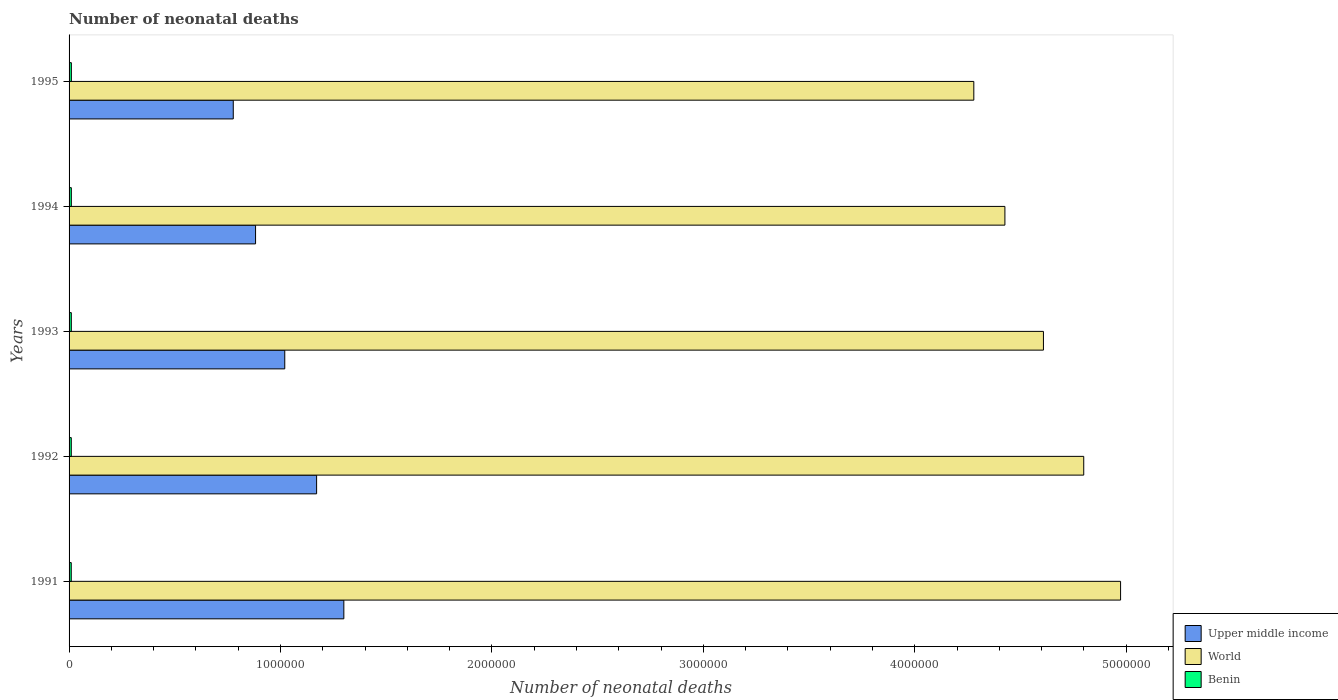How many different coloured bars are there?
Your answer should be compact. 3. How many groups of bars are there?
Provide a succinct answer. 5. How many bars are there on the 1st tick from the bottom?
Provide a short and direct response. 3. What is the label of the 3rd group of bars from the top?
Keep it short and to the point. 1993. In how many cases, is the number of bars for a given year not equal to the number of legend labels?
Offer a very short reply. 0. What is the number of neonatal deaths in in Upper middle income in 1994?
Your response must be concise. 8.82e+05. Across all years, what is the maximum number of neonatal deaths in in World?
Give a very brief answer. 4.97e+06. Across all years, what is the minimum number of neonatal deaths in in World?
Your response must be concise. 4.28e+06. In which year was the number of neonatal deaths in in Upper middle income minimum?
Provide a succinct answer. 1995. What is the total number of neonatal deaths in in Benin in the graph?
Offer a very short reply. 5.29e+04. What is the difference between the number of neonatal deaths in in Upper middle income in 1992 and that in 1993?
Your response must be concise. 1.51e+05. What is the difference between the number of neonatal deaths in in World in 1991 and the number of neonatal deaths in in Benin in 1995?
Your response must be concise. 4.96e+06. What is the average number of neonatal deaths in in Upper middle income per year?
Provide a short and direct response. 1.03e+06. In the year 1994, what is the difference between the number of neonatal deaths in in Benin and number of neonatal deaths in in Upper middle income?
Ensure brevity in your answer.  -8.71e+05. What is the ratio of the number of neonatal deaths in in World in 1991 to that in 1994?
Ensure brevity in your answer.  1.12. Is the difference between the number of neonatal deaths in in Benin in 1991 and 1993 greater than the difference between the number of neonatal deaths in in Upper middle income in 1991 and 1993?
Make the answer very short. No. What is the difference between the highest and the second highest number of neonatal deaths in in Benin?
Ensure brevity in your answer.  124. What is the difference between the highest and the lowest number of neonatal deaths in in World?
Offer a terse response. 6.94e+05. What does the 3rd bar from the top in 1992 represents?
Offer a very short reply. Upper middle income. What does the 1st bar from the bottom in 1993 represents?
Provide a succinct answer. Upper middle income. Is it the case that in every year, the sum of the number of neonatal deaths in in Benin and number of neonatal deaths in in Upper middle income is greater than the number of neonatal deaths in in World?
Provide a succinct answer. No. How many bars are there?
Keep it short and to the point. 15. What is the difference between two consecutive major ticks on the X-axis?
Give a very brief answer. 1.00e+06. Are the values on the major ticks of X-axis written in scientific E-notation?
Offer a very short reply. No. Where does the legend appear in the graph?
Offer a terse response. Bottom right. How many legend labels are there?
Your answer should be compact. 3. What is the title of the graph?
Your response must be concise. Number of neonatal deaths. Does "Ireland" appear as one of the legend labels in the graph?
Ensure brevity in your answer.  No. What is the label or title of the X-axis?
Ensure brevity in your answer.  Number of neonatal deaths. What is the Number of neonatal deaths in Upper middle income in 1991?
Your answer should be very brief. 1.30e+06. What is the Number of neonatal deaths of World in 1991?
Provide a succinct answer. 4.97e+06. What is the Number of neonatal deaths in Benin in 1991?
Offer a very short reply. 1.03e+04. What is the Number of neonatal deaths in Upper middle income in 1992?
Offer a very short reply. 1.17e+06. What is the Number of neonatal deaths in World in 1992?
Your response must be concise. 4.80e+06. What is the Number of neonatal deaths of Benin in 1992?
Your response must be concise. 1.04e+04. What is the Number of neonatal deaths of Upper middle income in 1993?
Offer a very short reply. 1.02e+06. What is the Number of neonatal deaths of World in 1993?
Your answer should be very brief. 4.61e+06. What is the Number of neonatal deaths of Benin in 1993?
Offer a very short reply. 1.06e+04. What is the Number of neonatal deaths in Upper middle income in 1994?
Offer a very short reply. 8.82e+05. What is the Number of neonatal deaths in World in 1994?
Your answer should be compact. 4.43e+06. What is the Number of neonatal deaths of Benin in 1994?
Provide a short and direct response. 1.07e+04. What is the Number of neonatal deaths of Upper middle income in 1995?
Provide a succinct answer. 7.77e+05. What is the Number of neonatal deaths in World in 1995?
Provide a short and direct response. 4.28e+06. What is the Number of neonatal deaths in Benin in 1995?
Offer a terse response. 1.08e+04. Across all years, what is the maximum Number of neonatal deaths in Upper middle income?
Give a very brief answer. 1.30e+06. Across all years, what is the maximum Number of neonatal deaths of World?
Provide a short and direct response. 4.97e+06. Across all years, what is the maximum Number of neonatal deaths of Benin?
Provide a succinct answer. 1.08e+04. Across all years, what is the minimum Number of neonatal deaths in Upper middle income?
Your answer should be very brief. 7.77e+05. Across all years, what is the minimum Number of neonatal deaths of World?
Make the answer very short. 4.28e+06. Across all years, what is the minimum Number of neonatal deaths in Benin?
Your response must be concise. 1.03e+04. What is the total Number of neonatal deaths of Upper middle income in the graph?
Make the answer very short. 5.15e+06. What is the total Number of neonatal deaths of World in the graph?
Your answer should be compact. 2.31e+07. What is the total Number of neonatal deaths of Benin in the graph?
Ensure brevity in your answer.  5.29e+04. What is the difference between the Number of neonatal deaths in Upper middle income in 1991 and that in 1992?
Give a very brief answer. 1.29e+05. What is the difference between the Number of neonatal deaths of World in 1991 and that in 1992?
Your response must be concise. 1.74e+05. What is the difference between the Number of neonatal deaths of Benin in 1991 and that in 1992?
Provide a short and direct response. -90. What is the difference between the Number of neonatal deaths in Upper middle income in 1991 and that in 1993?
Your answer should be compact. 2.79e+05. What is the difference between the Number of neonatal deaths of World in 1991 and that in 1993?
Give a very brief answer. 3.65e+05. What is the difference between the Number of neonatal deaths of Benin in 1991 and that in 1993?
Give a very brief answer. -228. What is the difference between the Number of neonatal deaths of Upper middle income in 1991 and that in 1994?
Offer a very short reply. 4.18e+05. What is the difference between the Number of neonatal deaths of World in 1991 and that in 1994?
Your answer should be very brief. 5.47e+05. What is the difference between the Number of neonatal deaths of Benin in 1991 and that in 1994?
Give a very brief answer. -367. What is the difference between the Number of neonatal deaths of Upper middle income in 1991 and that in 1995?
Offer a very short reply. 5.23e+05. What is the difference between the Number of neonatal deaths of World in 1991 and that in 1995?
Ensure brevity in your answer.  6.94e+05. What is the difference between the Number of neonatal deaths in Benin in 1991 and that in 1995?
Provide a short and direct response. -491. What is the difference between the Number of neonatal deaths in Upper middle income in 1992 and that in 1993?
Your answer should be very brief. 1.51e+05. What is the difference between the Number of neonatal deaths in World in 1992 and that in 1993?
Keep it short and to the point. 1.91e+05. What is the difference between the Number of neonatal deaths in Benin in 1992 and that in 1993?
Ensure brevity in your answer.  -138. What is the difference between the Number of neonatal deaths of Upper middle income in 1992 and that in 1994?
Your answer should be compact. 2.89e+05. What is the difference between the Number of neonatal deaths in World in 1992 and that in 1994?
Offer a terse response. 3.73e+05. What is the difference between the Number of neonatal deaths of Benin in 1992 and that in 1994?
Give a very brief answer. -277. What is the difference between the Number of neonatal deaths in Upper middle income in 1992 and that in 1995?
Keep it short and to the point. 3.94e+05. What is the difference between the Number of neonatal deaths of World in 1992 and that in 1995?
Give a very brief answer. 5.20e+05. What is the difference between the Number of neonatal deaths in Benin in 1992 and that in 1995?
Make the answer very short. -401. What is the difference between the Number of neonatal deaths in Upper middle income in 1993 and that in 1994?
Your answer should be very brief. 1.38e+05. What is the difference between the Number of neonatal deaths of World in 1993 and that in 1994?
Offer a terse response. 1.82e+05. What is the difference between the Number of neonatal deaths of Benin in 1993 and that in 1994?
Your response must be concise. -139. What is the difference between the Number of neonatal deaths in Upper middle income in 1993 and that in 1995?
Keep it short and to the point. 2.44e+05. What is the difference between the Number of neonatal deaths in World in 1993 and that in 1995?
Offer a terse response. 3.29e+05. What is the difference between the Number of neonatal deaths in Benin in 1993 and that in 1995?
Provide a succinct answer. -263. What is the difference between the Number of neonatal deaths of Upper middle income in 1994 and that in 1995?
Provide a short and direct response. 1.05e+05. What is the difference between the Number of neonatal deaths in World in 1994 and that in 1995?
Provide a short and direct response. 1.47e+05. What is the difference between the Number of neonatal deaths of Benin in 1994 and that in 1995?
Offer a very short reply. -124. What is the difference between the Number of neonatal deaths of Upper middle income in 1991 and the Number of neonatal deaths of World in 1992?
Make the answer very short. -3.50e+06. What is the difference between the Number of neonatal deaths in Upper middle income in 1991 and the Number of neonatal deaths in Benin in 1992?
Make the answer very short. 1.29e+06. What is the difference between the Number of neonatal deaths of World in 1991 and the Number of neonatal deaths of Benin in 1992?
Your answer should be compact. 4.96e+06. What is the difference between the Number of neonatal deaths in Upper middle income in 1991 and the Number of neonatal deaths in World in 1993?
Provide a succinct answer. -3.31e+06. What is the difference between the Number of neonatal deaths of Upper middle income in 1991 and the Number of neonatal deaths of Benin in 1993?
Give a very brief answer. 1.29e+06. What is the difference between the Number of neonatal deaths in World in 1991 and the Number of neonatal deaths in Benin in 1993?
Provide a short and direct response. 4.96e+06. What is the difference between the Number of neonatal deaths in Upper middle income in 1991 and the Number of neonatal deaths in World in 1994?
Give a very brief answer. -3.13e+06. What is the difference between the Number of neonatal deaths of Upper middle income in 1991 and the Number of neonatal deaths of Benin in 1994?
Provide a succinct answer. 1.29e+06. What is the difference between the Number of neonatal deaths of World in 1991 and the Number of neonatal deaths of Benin in 1994?
Offer a terse response. 4.96e+06. What is the difference between the Number of neonatal deaths in Upper middle income in 1991 and the Number of neonatal deaths in World in 1995?
Offer a very short reply. -2.98e+06. What is the difference between the Number of neonatal deaths of Upper middle income in 1991 and the Number of neonatal deaths of Benin in 1995?
Provide a short and direct response. 1.29e+06. What is the difference between the Number of neonatal deaths in World in 1991 and the Number of neonatal deaths in Benin in 1995?
Ensure brevity in your answer.  4.96e+06. What is the difference between the Number of neonatal deaths of Upper middle income in 1992 and the Number of neonatal deaths of World in 1993?
Make the answer very short. -3.44e+06. What is the difference between the Number of neonatal deaths of Upper middle income in 1992 and the Number of neonatal deaths of Benin in 1993?
Offer a very short reply. 1.16e+06. What is the difference between the Number of neonatal deaths of World in 1992 and the Number of neonatal deaths of Benin in 1993?
Keep it short and to the point. 4.79e+06. What is the difference between the Number of neonatal deaths of Upper middle income in 1992 and the Number of neonatal deaths of World in 1994?
Offer a very short reply. -3.26e+06. What is the difference between the Number of neonatal deaths of Upper middle income in 1992 and the Number of neonatal deaths of Benin in 1994?
Offer a terse response. 1.16e+06. What is the difference between the Number of neonatal deaths of World in 1992 and the Number of neonatal deaths of Benin in 1994?
Provide a short and direct response. 4.79e+06. What is the difference between the Number of neonatal deaths in Upper middle income in 1992 and the Number of neonatal deaths in World in 1995?
Ensure brevity in your answer.  -3.11e+06. What is the difference between the Number of neonatal deaths of Upper middle income in 1992 and the Number of neonatal deaths of Benin in 1995?
Your response must be concise. 1.16e+06. What is the difference between the Number of neonatal deaths in World in 1992 and the Number of neonatal deaths in Benin in 1995?
Offer a very short reply. 4.79e+06. What is the difference between the Number of neonatal deaths of Upper middle income in 1993 and the Number of neonatal deaths of World in 1994?
Provide a succinct answer. -3.41e+06. What is the difference between the Number of neonatal deaths in Upper middle income in 1993 and the Number of neonatal deaths in Benin in 1994?
Your answer should be compact. 1.01e+06. What is the difference between the Number of neonatal deaths of World in 1993 and the Number of neonatal deaths of Benin in 1994?
Your answer should be compact. 4.60e+06. What is the difference between the Number of neonatal deaths of Upper middle income in 1993 and the Number of neonatal deaths of World in 1995?
Offer a very short reply. -3.26e+06. What is the difference between the Number of neonatal deaths of Upper middle income in 1993 and the Number of neonatal deaths of Benin in 1995?
Your response must be concise. 1.01e+06. What is the difference between the Number of neonatal deaths of World in 1993 and the Number of neonatal deaths of Benin in 1995?
Your answer should be very brief. 4.60e+06. What is the difference between the Number of neonatal deaths of Upper middle income in 1994 and the Number of neonatal deaths of World in 1995?
Keep it short and to the point. -3.40e+06. What is the difference between the Number of neonatal deaths in Upper middle income in 1994 and the Number of neonatal deaths in Benin in 1995?
Make the answer very short. 8.71e+05. What is the difference between the Number of neonatal deaths in World in 1994 and the Number of neonatal deaths in Benin in 1995?
Your answer should be compact. 4.42e+06. What is the average Number of neonatal deaths of Upper middle income per year?
Keep it short and to the point. 1.03e+06. What is the average Number of neonatal deaths of World per year?
Ensure brevity in your answer.  4.62e+06. What is the average Number of neonatal deaths in Benin per year?
Your response must be concise. 1.06e+04. In the year 1991, what is the difference between the Number of neonatal deaths of Upper middle income and Number of neonatal deaths of World?
Offer a very short reply. -3.67e+06. In the year 1991, what is the difference between the Number of neonatal deaths in Upper middle income and Number of neonatal deaths in Benin?
Your answer should be compact. 1.29e+06. In the year 1991, what is the difference between the Number of neonatal deaths in World and Number of neonatal deaths in Benin?
Your answer should be very brief. 4.96e+06. In the year 1992, what is the difference between the Number of neonatal deaths in Upper middle income and Number of neonatal deaths in World?
Offer a terse response. -3.63e+06. In the year 1992, what is the difference between the Number of neonatal deaths in Upper middle income and Number of neonatal deaths in Benin?
Give a very brief answer. 1.16e+06. In the year 1992, what is the difference between the Number of neonatal deaths of World and Number of neonatal deaths of Benin?
Give a very brief answer. 4.79e+06. In the year 1993, what is the difference between the Number of neonatal deaths in Upper middle income and Number of neonatal deaths in World?
Ensure brevity in your answer.  -3.59e+06. In the year 1993, what is the difference between the Number of neonatal deaths of Upper middle income and Number of neonatal deaths of Benin?
Your answer should be very brief. 1.01e+06. In the year 1993, what is the difference between the Number of neonatal deaths in World and Number of neonatal deaths in Benin?
Provide a succinct answer. 4.60e+06. In the year 1994, what is the difference between the Number of neonatal deaths in Upper middle income and Number of neonatal deaths in World?
Keep it short and to the point. -3.54e+06. In the year 1994, what is the difference between the Number of neonatal deaths of Upper middle income and Number of neonatal deaths of Benin?
Your answer should be very brief. 8.71e+05. In the year 1994, what is the difference between the Number of neonatal deaths of World and Number of neonatal deaths of Benin?
Ensure brevity in your answer.  4.42e+06. In the year 1995, what is the difference between the Number of neonatal deaths of Upper middle income and Number of neonatal deaths of World?
Give a very brief answer. -3.50e+06. In the year 1995, what is the difference between the Number of neonatal deaths of Upper middle income and Number of neonatal deaths of Benin?
Provide a succinct answer. 7.66e+05. In the year 1995, what is the difference between the Number of neonatal deaths of World and Number of neonatal deaths of Benin?
Offer a terse response. 4.27e+06. What is the ratio of the Number of neonatal deaths in Upper middle income in 1991 to that in 1992?
Give a very brief answer. 1.11. What is the ratio of the Number of neonatal deaths in World in 1991 to that in 1992?
Make the answer very short. 1.04. What is the ratio of the Number of neonatal deaths of Benin in 1991 to that in 1992?
Your answer should be compact. 0.99. What is the ratio of the Number of neonatal deaths of Upper middle income in 1991 to that in 1993?
Your answer should be very brief. 1.27. What is the ratio of the Number of neonatal deaths of World in 1991 to that in 1993?
Give a very brief answer. 1.08. What is the ratio of the Number of neonatal deaths of Benin in 1991 to that in 1993?
Provide a short and direct response. 0.98. What is the ratio of the Number of neonatal deaths in Upper middle income in 1991 to that in 1994?
Provide a succinct answer. 1.47. What is the ratio of the Number of neonatal deaths in World in 1991 to that in 1994?
Ensure brevity in your answer.  1.12. What is the ratio of the Number of neonatal deaths in Benin in 1991 to that in 1994?
Offer a terse response. 0.97. What is the ratio of the Number of neonatal deaths of Upper middle income in 1991 to that in 1995?
Offer a terse response. 1.67. What is the ratio of the Number of neonatal deaths of World in 1991 to that in 1995?
Your answer should be compact. 1.16. What is the ratio of the Number of neonatal deaths of Benin in 1991 to that in 1995?
Keep it short and to the point. 0.95. What is the ratio of the Number of neonatal deaths in Upper middle income in 1992 to that in 1993?
Keep it short and to the point. 1.15. What is the ratio of the Number of neonatal deaths of World in 1992 to that in 1993?
Provide a succinct answer. 1.04. What is the ratio of the Number of neonatal deaths in Benin in 1992 to that in 1993?
Your answer should be very brief. 0.99. What is the ratio of the Number of neonatal deaths in Upper middle income in 1992 to that in 1994?
Ensure brevity in your answer.  1.33. What is the ratio of the Number of neonatal deaths of World in 1992 to that in 1994?
Give a very brief answer. 1.08. What is the ratio of the Number of neonatal deaths in Benin in 1992 to that in 1994?
Provide a short and direct response. 0.97. What is the ratio of the Number of neonatal deaths in Upper middle income in 1992 to that in 1995?
Offer a very short reply. 1.51. What is the ratio of the Number of neonatal deaths of World in 1992 to that in 1995?
Make the answer very short. 1.12. What is the ratio of the Number of neonatal deaths of Upper middle income in 1993 to that in 1994?
Give a very brief answer. 1.16. What is the ratio of the Number of neonatal deaths in World in 1993 to that in 1994?
Make the answer very short. 1.04. What is the ratio of the Number of neonatal deaths of Benin in 1993 to that in 1994?
Provide a short and direct response. 0.99. What is the ratio of the Number of neonatal deaths of Upper middle income in 1993 to that in 1995?
Make the answer very short. 1.31. What is the ratio of the Number of neonatal deaths in World in 1993 to that in 1995?
Offer a very short reply. 1.08. What is the ratio of the Number of neonatal deaths of Benin in 1993 to that in 1995?
Provide a succinct answer. 0.98. What is the ratio of the Number of neonatal deaths of Upper middle income in 1994 to that in 1995?
Offer a very short reply. 1.14. What is the ratio of the Number of neonatal deaths in World in 1994 to that in 1995?
Your response must be concise. 1.03. What is the ratio of the Number of neonatal deaths of Benin in 1994 to that in 1995?
Provide a short and direct response. 0.99. What is the difference between the highest and the second highest Number of neonatal deaths in Upper middle income?
Offer a very short reply. 1.29e+05. What is the difference between the highest and the second highest Number of neonatal deaths in World?
Offer a very short reply. 1.74e+05. What is the difference between the highest and the second highest Number of neonatal deaths of Benin?
Your answer should be compact. 124. What is the difference between the highest and the lowest Number of neonatal deaths in Upper middle income?
Offer a terse response. 5.23e+05. What is the difference between the highest and the lowest Number of neonatal deaths of World?
Keep it short and to the point. 6.94e+05. What is the difference between the highest and the lowest Number of neonatal deaths of Benin?
Offer a very short reply. 491. 